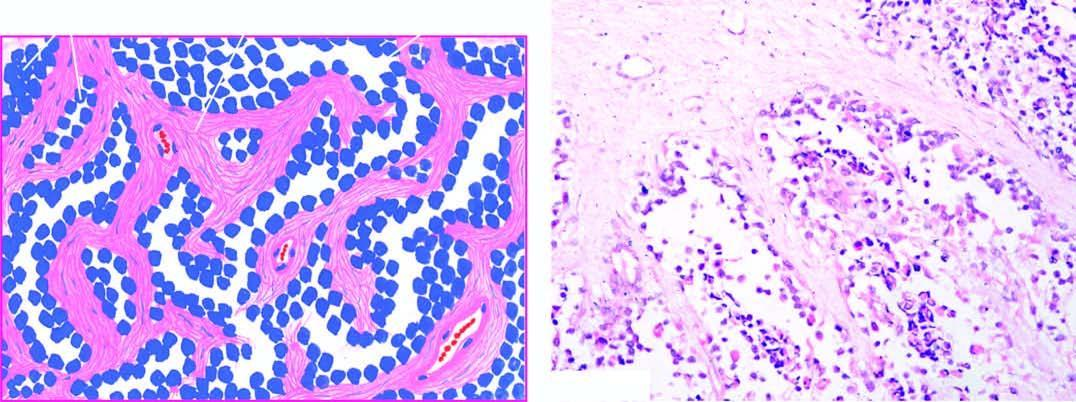what are also present?
Answer the question using a single word or phrase. A few multinucleate tumour giant cells 